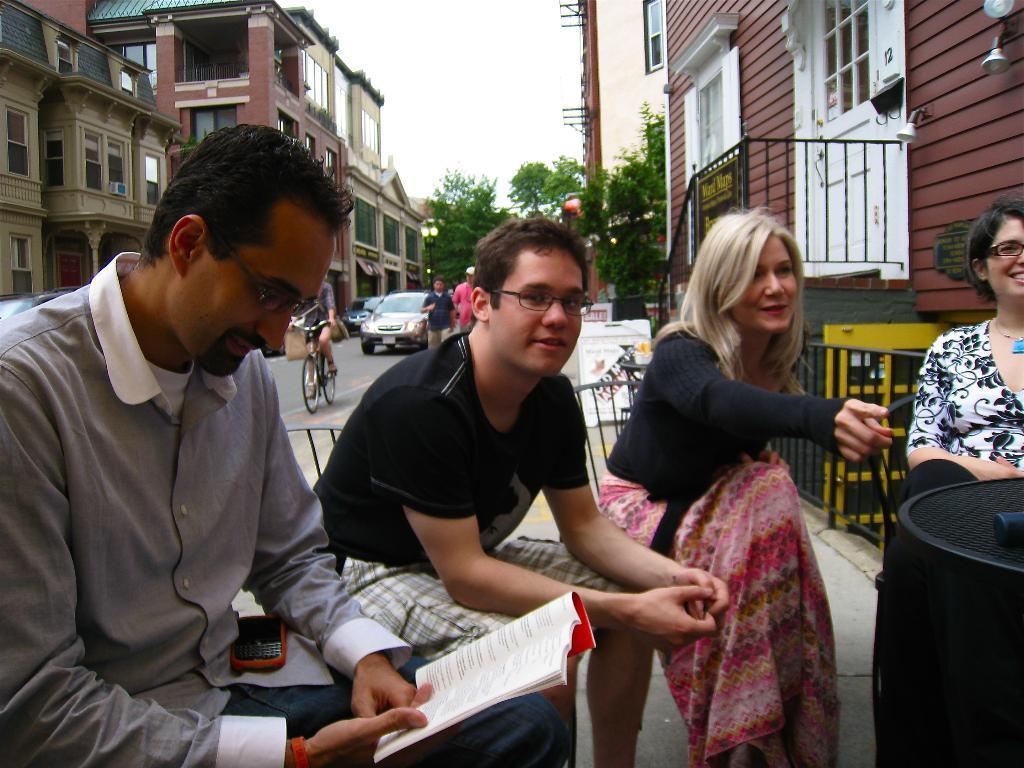Could you give a brief overview of what you see in this image? In this picture I can see some vehicles are on the roadside few people are sitting on the chairs, around I can see some buildings, trees. 